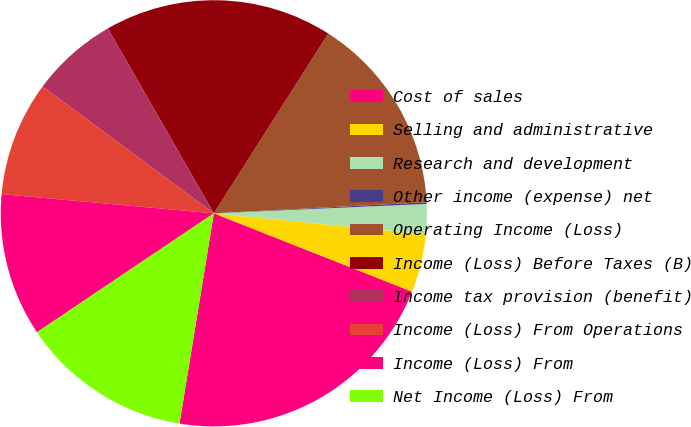Convert chart to OTSL. <chart><loc_0><loc_0><loc_500><loc_500><pie_chart><fcel>Cost of sales<fcel>Selling and administrative<fcel>Research and development<fcel>Other income (expense) net<fcel>Operating Income (Loss)<fcel>Income (Loss) Before Taxes (B)<fcel>Income tax provision (benefit)<fcel>Income (Loss) From Operations<fcel>Income (Loss) From<fcel>Net Income (Loss) From<nl><fcel>21.59%<fcel>4.42%<fcel>2.27%<fcel>0.13%<fcel>15.15%<fcel>17.3%<fcel>6.57%<fcel>8.71%<fcel>10.86%<fcel>13.0%<nl></chart> 